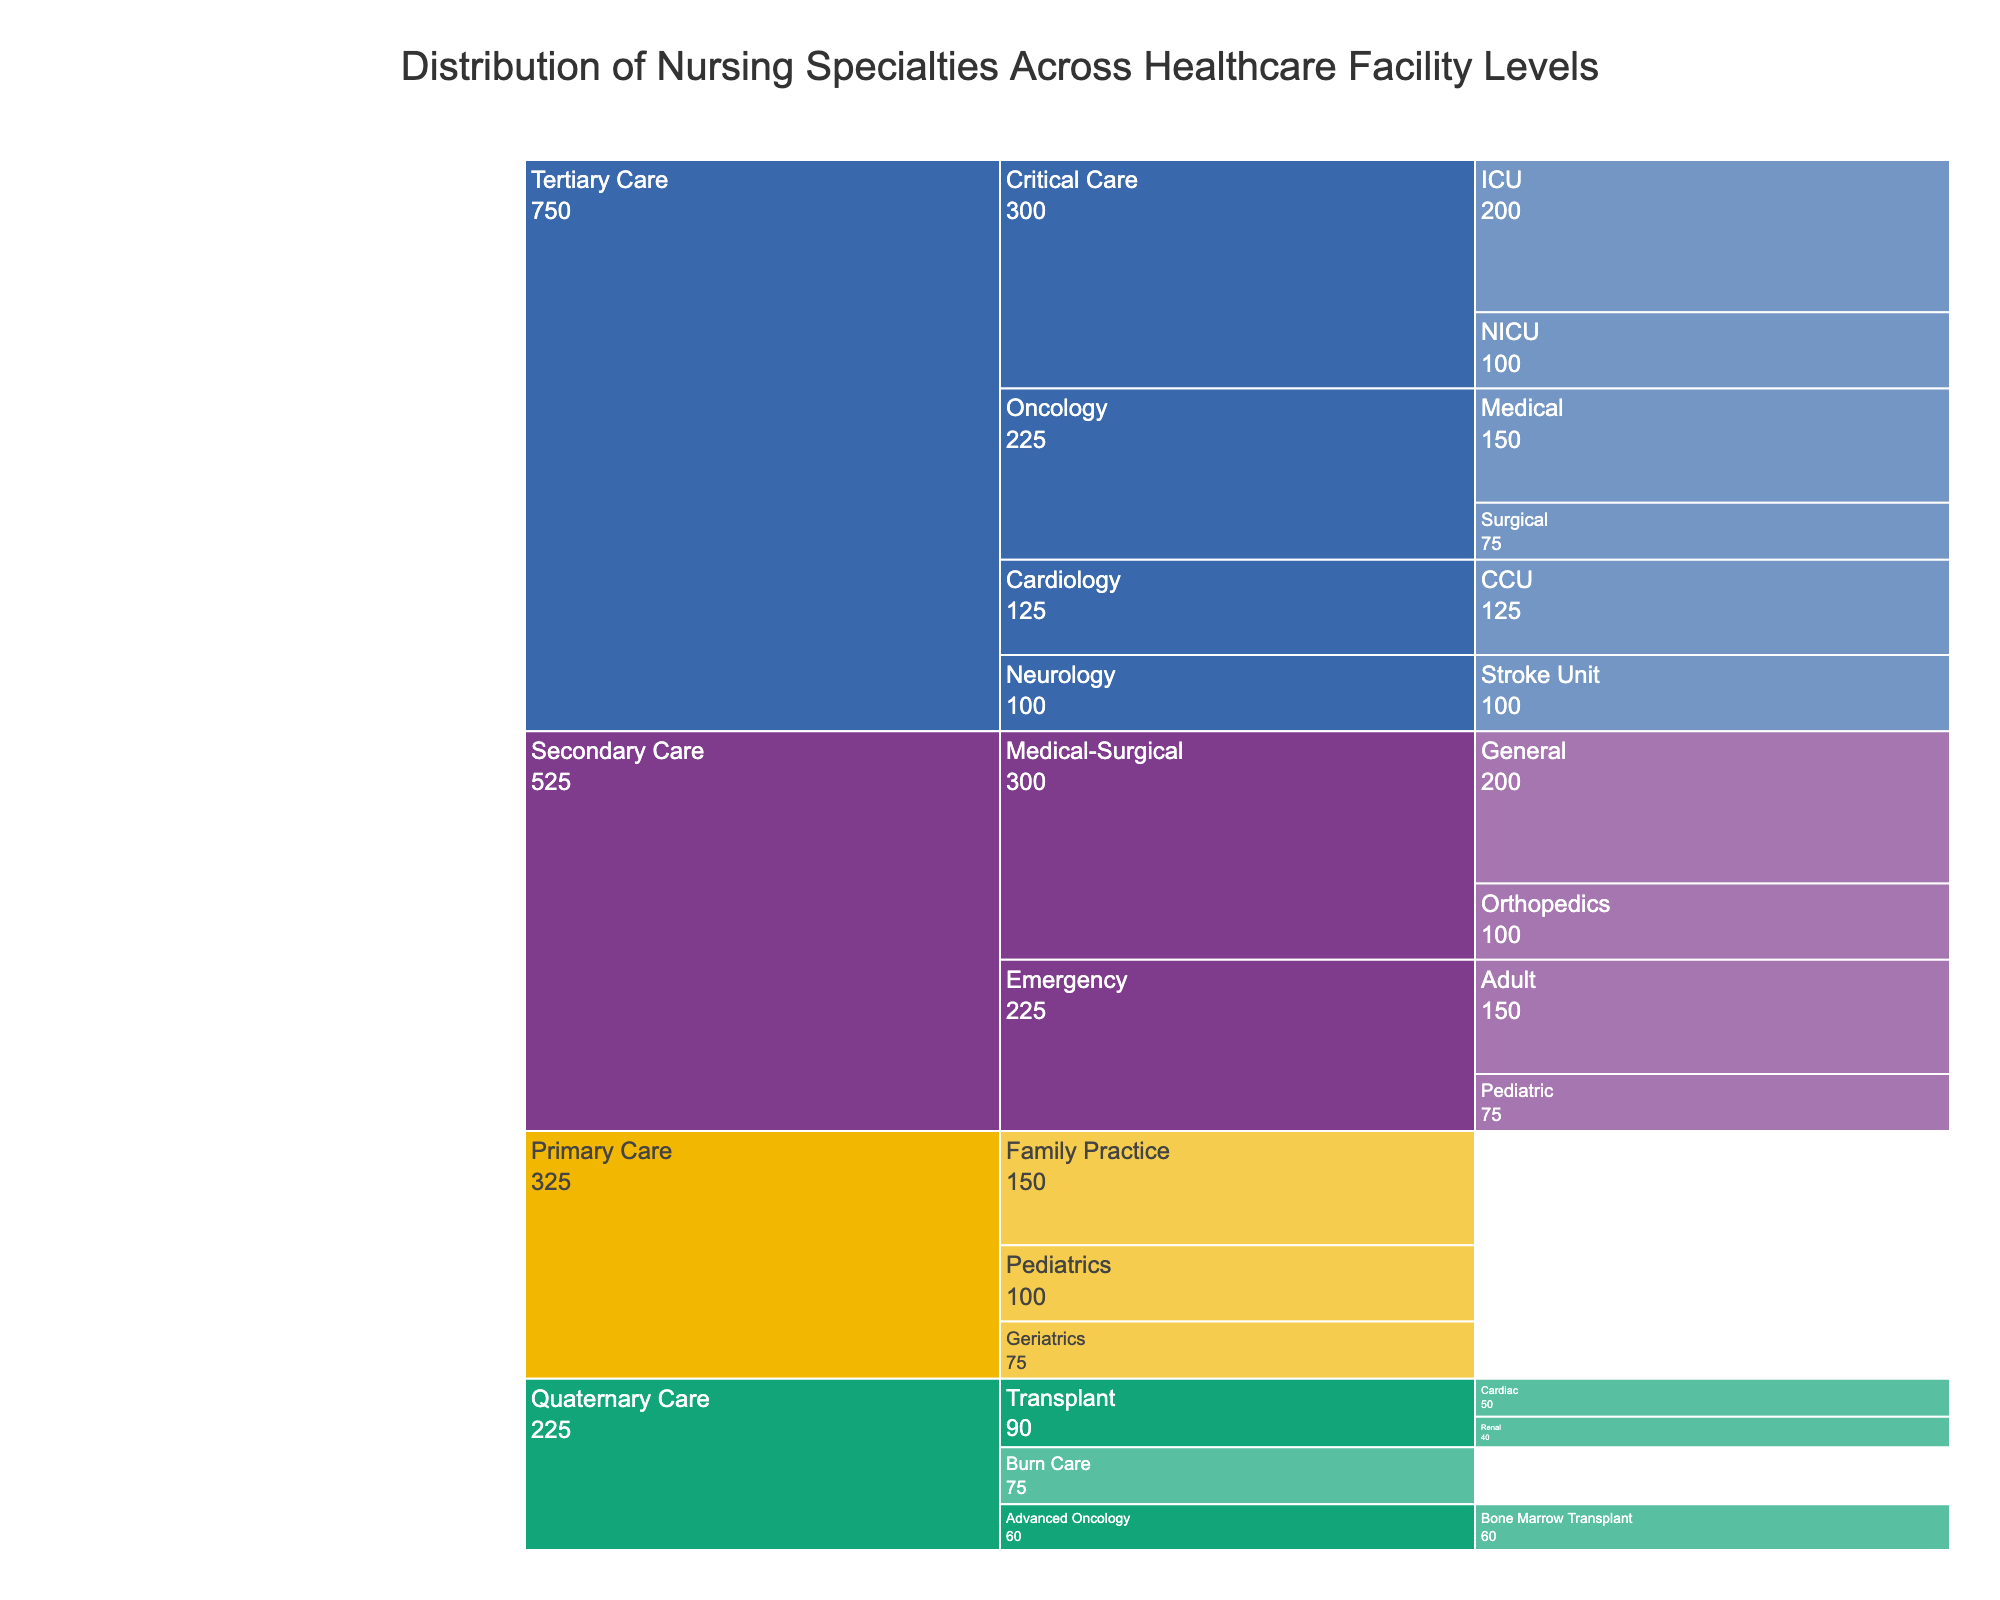What is the title of the figure? The title is prominently displayed at the top of the figure.
Answer: Distribution of Nursing Specialties Across Healthcare Facility Levels How many major healthcare facility levels are represented? The Icicle chart lists the main healthcare facility levels as distinct colors and blocks at the top level of the chart.
Answer: Four Which healthcare facility level has the highest number of nurses? Sum the number of nurses for each facility level and find the maximum. Tertiary Care has the highest with 750 nurses (200 + 100 + 150 + 75 + 125 + 100).
Answer: Tertiary Care How many nurses work in Pediatric Emergency departments in Secondary Care facilities? Navigate from Secondary Care --> Emergency --> Pediatric in the Icicle chart to find the number associated with Pediatric Emergency.
Answer: 75 Compare the number of nurses in Family Practice and Geriatrics in Primary Care. Which specialty has more? Compare the numbers directly: Family Practice (150) vs. Geriatrics (75). Family Practice has more nurses.
Answer: Family Practice How many specialties are listed under Tertiary Care? Count the unique specialties within the Tertiary Care section of the Icicle chart. The specialties are Critical Care, Oncology, Cardiology, and Neurology.
Answer: Four What is the total number of nurses in the Critical Care specialty for Tertiary Care facilities? Add the numbers of nurses in all sub-specialties under Critical Care in Tertiary Care: ICU (200) + NICU (100) = 300.
Answer: 300 Which healthcare facility level has the fewest nurses in the Transplant specialty? Look at the Transplant specialty under Quaternary Care and compare the number for each sub-specialty: Cardiac (50) and Renal (40). Renal is fewer.
Answer: Renal Which specialty in Quaternary Care has the smallest number of nurses, and how many? Compare numbers for all specialties and sub-specialties under Quaternary Care: Transplant/Cardiac (50), Transplant/Renal (40), Burn Care (75), Advanced Oncology/Bone Marrow Transplant (60). Transplant/Renal has the smallest with 40 nurses.
Answer: Transplant/Renal, 40 How does the number of nurses in Secondary Care compare between Emergency (Adult and Pediatric combined) and Medical-Surgical (General and Orthopedics combined)? Sum the numbers: Emergency (Adult 150 + Pediatric 75 = 225), Medical-Surgical (General 200 + Orthopedics 100 = 300). Medical-Surgical has more nurses.
Answer: Medical-Surgical has more 